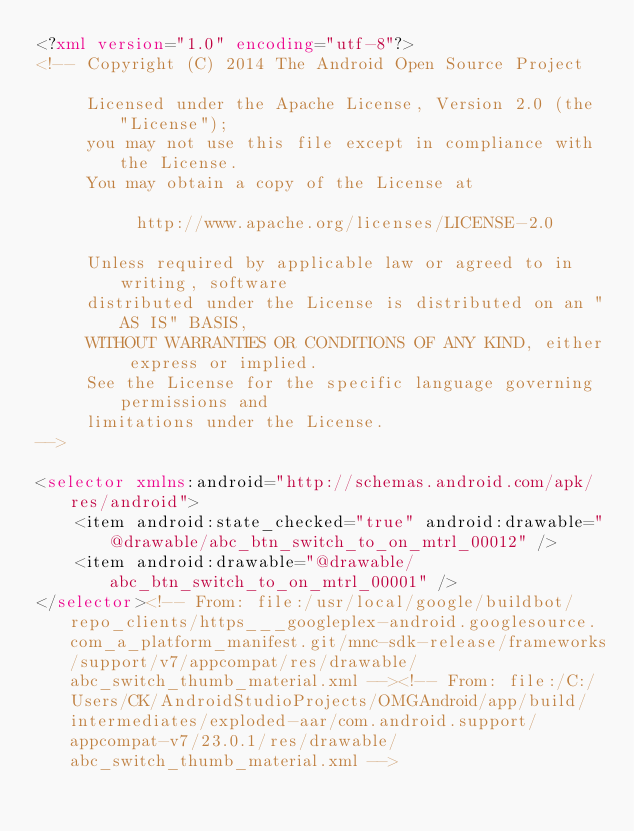<code> <loc_0><loc_0><loc_500><loc_500><_XML_><?xml version="1.0" encoding="utf-8"?>
<!-- Copyright (C) 2014 The Android Open Source Project

     Licensed under the Apache License, Version 2.0 (the "License");
     you may not use this file except in compliance with the License.
     You may obtain a copy of the License at

          http://www.apache.org/licenses/LICENSE-2.0

     Unless required by applicable law or agreed to in writing, software
     distributed under the License is distributed on an "AS IS" BASIS,
     WITHOUT WARRANTIES OR CONDITIONS OF ANY KIND, either express or implied.
     See the License for the specific language governing permissions and
     limitations under the License.
-->

<selector xmlns:android="http://schemas.android.com/apk/res/android">
    <item android:state_checked="true" android:drawable="@drawable/abc_btn_switch_to_on_mtrl_00012" />
    <item android:drawable="@drawable/abc_btn_switch_to_on_mtrl_00001" />
</selector><!-- From: file:/usr/local/google/buildbot/repo_clients/https___googleplex-android.googlesource.com_a_platform_manifest.git/mnc-sdk-release/frameworks/support/v7/appcompat/res/drawable/abc_switch_thumb_material.xml --><!-- From: file:/C:/Users/CK/AndroidStudioProjects/OMGAndroid/app/build/intermediates/exploded-aar/com.android.support/appcompat-v7/23.0.1/res/drawable/abc_switch_thumb_material.xml --></code> 